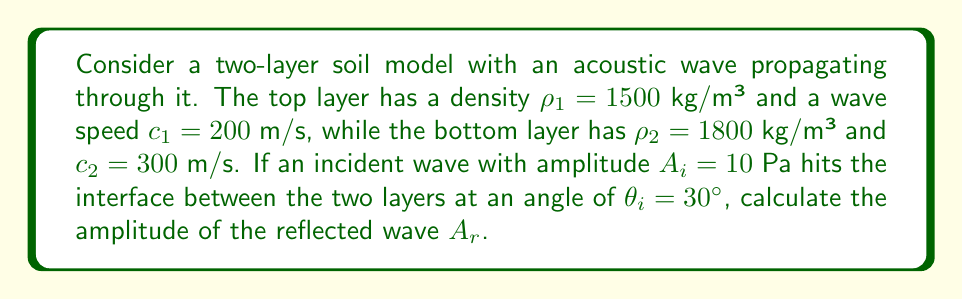Solve this math problem. To solve this problem, we'll use the acoustic reflection coefficient formula and Snell's law:

1) First, we need to find the transmission angle $\theta_t$ using Snell's law:

   $$\frac{\sin \theta_i}{c_1} = \frac{\sin \theta_t}{c_2}$$

   $$\sin \theta_t = \frac{c_2 \sin \theta_i}{c_1} = \frac{300 \cdot \sin 30°}{200} = 0.75$$

   $$\theta_t = \arcsin(0.75) \approx 48.59°$$

2) Now, we can calculate the acoustic impedances:

   $$Z_1 = \rho_1 c_1 = 1500 \cdot 200 = 300,000 \text{ kg/(m²s)}$$
   $$Z_2 = \rho_2 c_2 = 1800 \cdot 300 = 540,000 \text{ kg/(m²s)}$$

3) The reflection coefficient $R$ is given by:

   $$R = \frac{Z_2 \cos \theta_i - Z_1 \cos \theta_t}{Z_2 \cos \theta_i + Z_1 \cos \theta_t}$$

4) Substituting the values:

   $$R = \frac{540,000 \cdot \cos 30° - 300,000 \cdot \cos 48.59°}{540,000 \cdot \cos 30° + 300,000 \cdot \cos 48.59°}$$

   $$R \approx 0.4142$$

5) The amplitude of the reflected wave is given by:

   $$A_r = R \cdot A_i = 0.4142 \cdot 10 \approx 4.142 \text{ Pa}$$
Answer: $A_r \approx 4.142$ Pa 